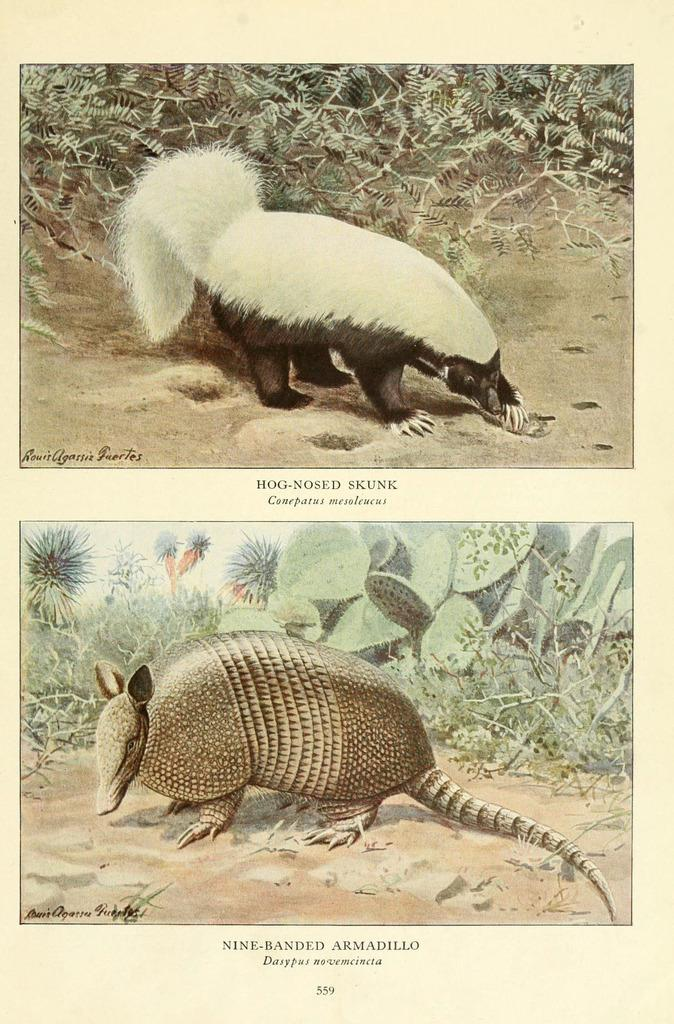What is depicted on the paper in the image? The paper contains a drawing of animals. What else can be seen in the drawing besides the animals? The drawing includes grass. How does the heat affect the dirt in the image? There is no heat or dirt present in the image; it only contains a drawing of animals and grass on a paper. 